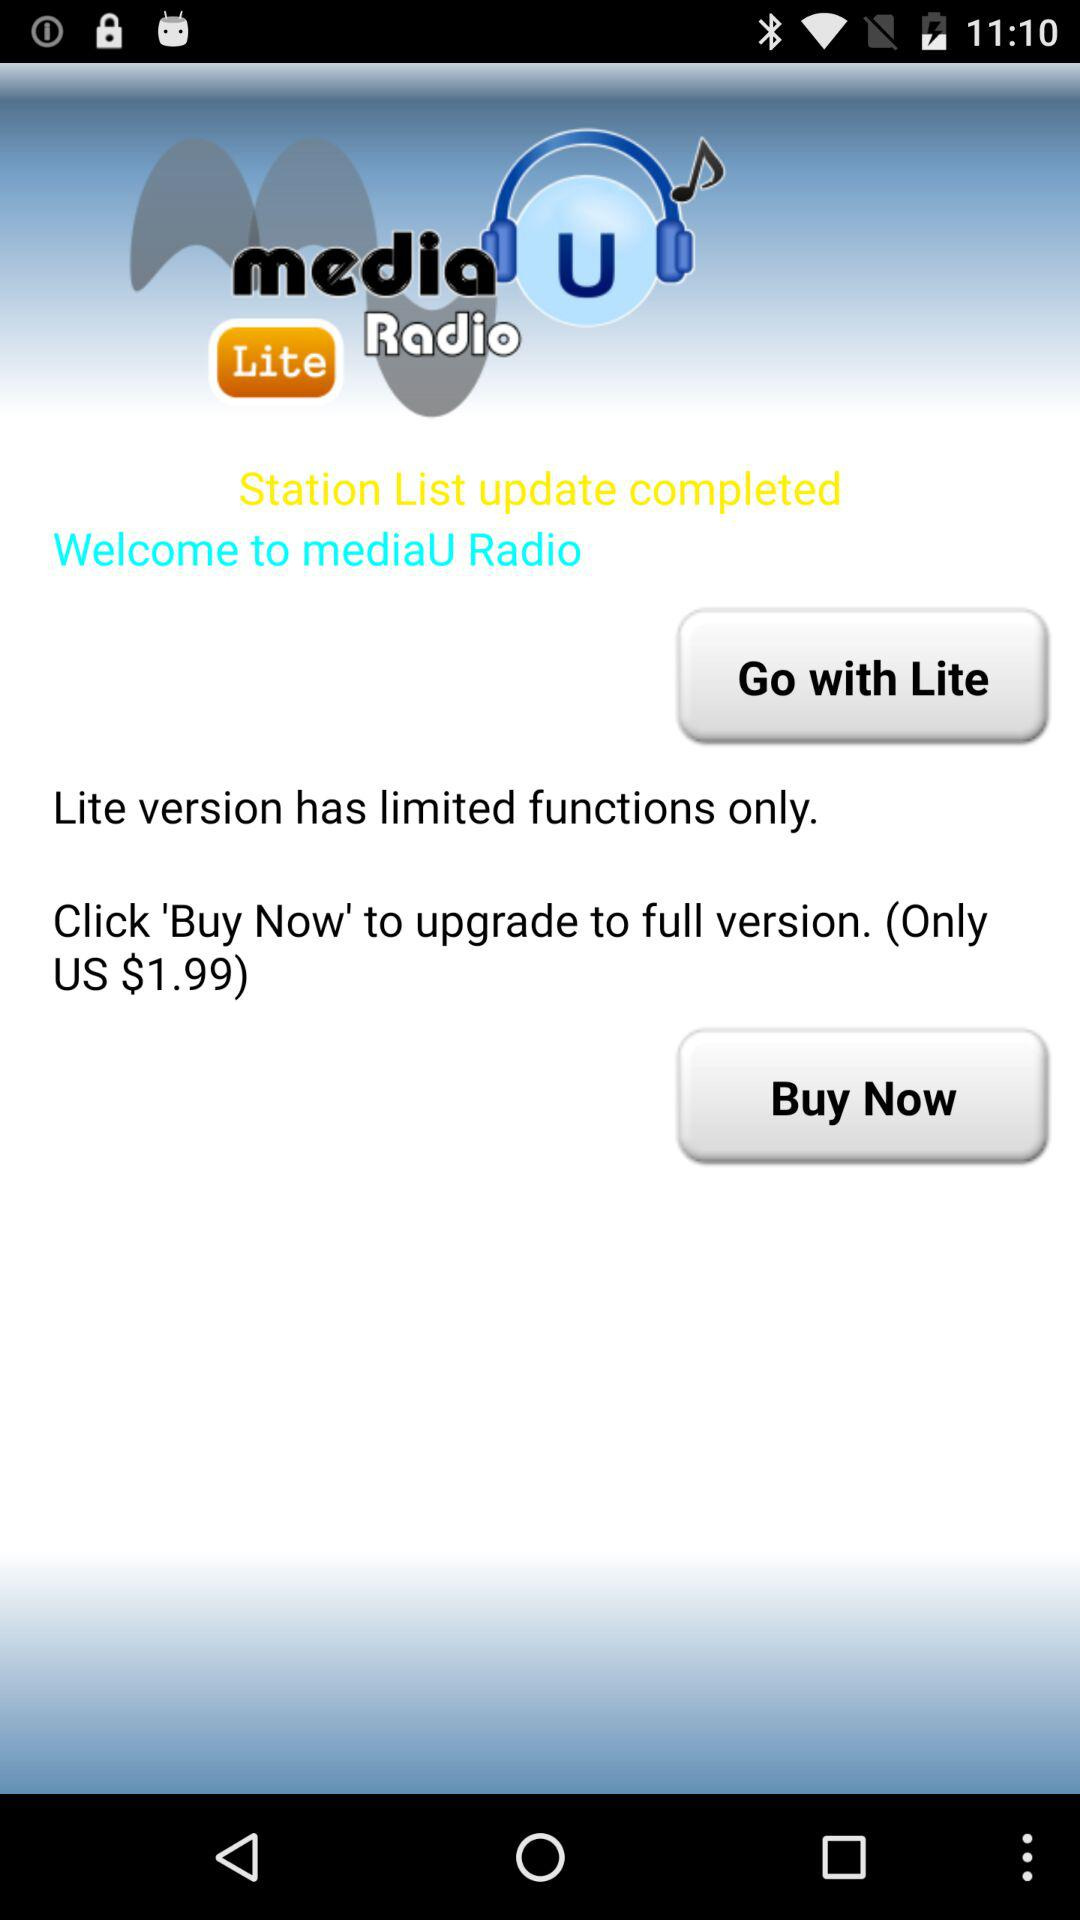What is the name of the application? The name of the application is "mediaU Radio". 